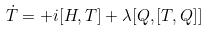Convert formula to latex. <formula><loc_0><loc_0><loc_500><loc_500>\dot { T } = + i [ H , T ] + \lambda [ Q , [ T , Q ] ]</formula> 